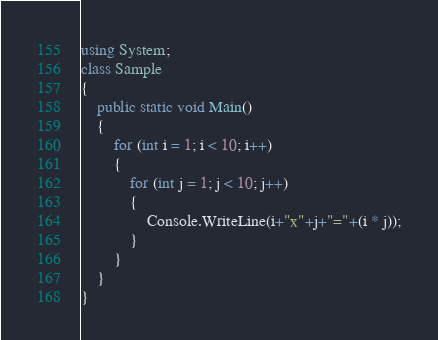<code> <loc_0><loc_0><loc_500><loc_500><_C#_>using System;
class Sample
{
    public static void Main()
    {
        for (int i = 1; i < 10; i++)
        {
            for (int j = 1; j < 10; j++)
            {
                Console.WriteLine(i+"x"+j+"="+(i * j));
            }
        }
    }
}</code> 